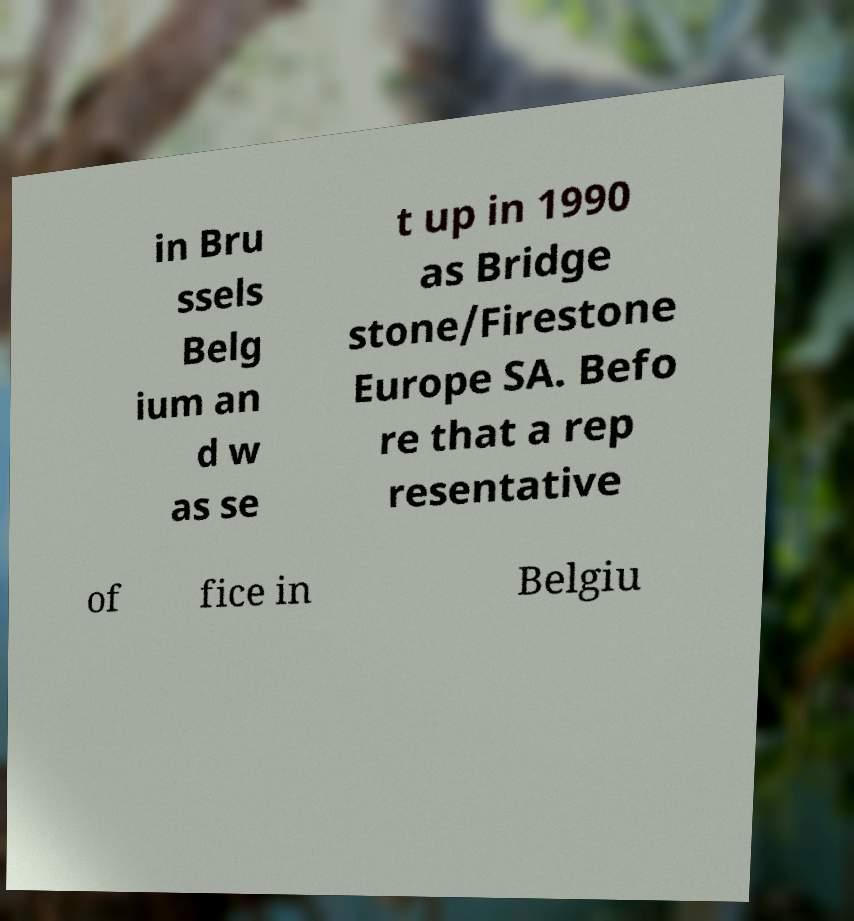There's text embedded in this image that I need extracted. Can you transcribe it verbatim? in Bru ssels Belg ium an d w as se t up in 1990 as Bridge stone/Firestone Europe SA. Befo re that a rep resentative of fice in Belgiu 